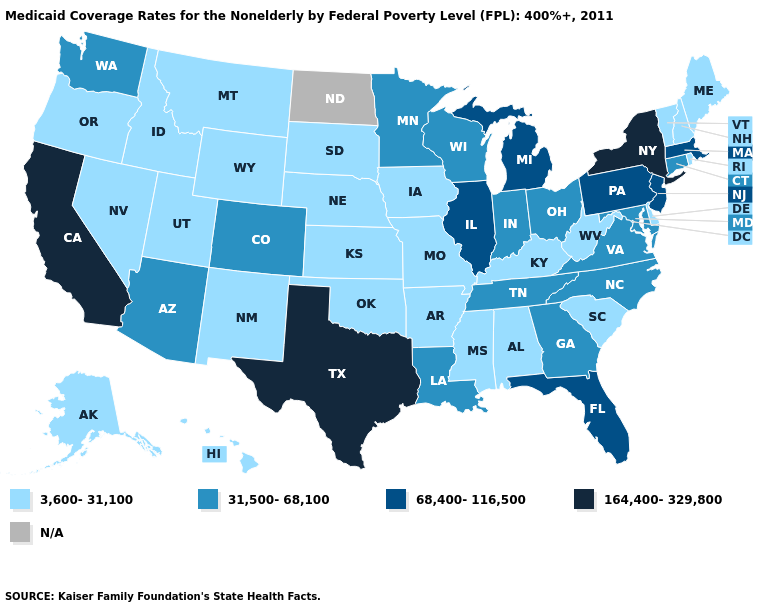What is the value of Pennsylvania?
Quick response, please. 68,400-116,500. What is the value of Florida?
Give a very brief answer. 68,400-116,500. Name the states that have a value in the range N/A?
Answer briefly. North Dakota. Name the states that have a value in the range 3,600-31,100?
Short answer required. Alabama, Alaska, Arkansas, Delaware, Hawaii, Idaho, Iowa, Kansas, Kentucky, Maine, Mississippi, Missouri, Montana, Nebraska, Nevada, New Hampshire, New Mexico, Oklahoma, Oregon, Rhode Island, South Carolina, South Dakota, Utah, Vermont, West Virginia, Wyoming. Name the states that have a value in the range 164,400-329,800?
Give a very brief answer. California, New York, Texas. Does Connecticut have the lowest value in the USA?
Write a very short answer. No. Does the map have missing data?
Write a very short answer. Yes. What is the value of Iowa?
Give a very brief answer. 3,600-31,100. What is the value of South Carolina?
Be succinct. 3,600-31,100. Which states hav the highest value in the West?
Write a very short answer. California. Name the states that have a value in the range 68,400-116,500?
Concise answer only. Florida, Illinois, Massachusetts, Michigan, New Jersey, Pennsylvania. What is the value of Connecticut?
Give a very brief answer. 31,500-68,100. Name the states that have a value in the range 164,400-329,800?
Concise answer only. California, New York, Texas. Which states hav the highest value in the West?
Short answer required. California. 